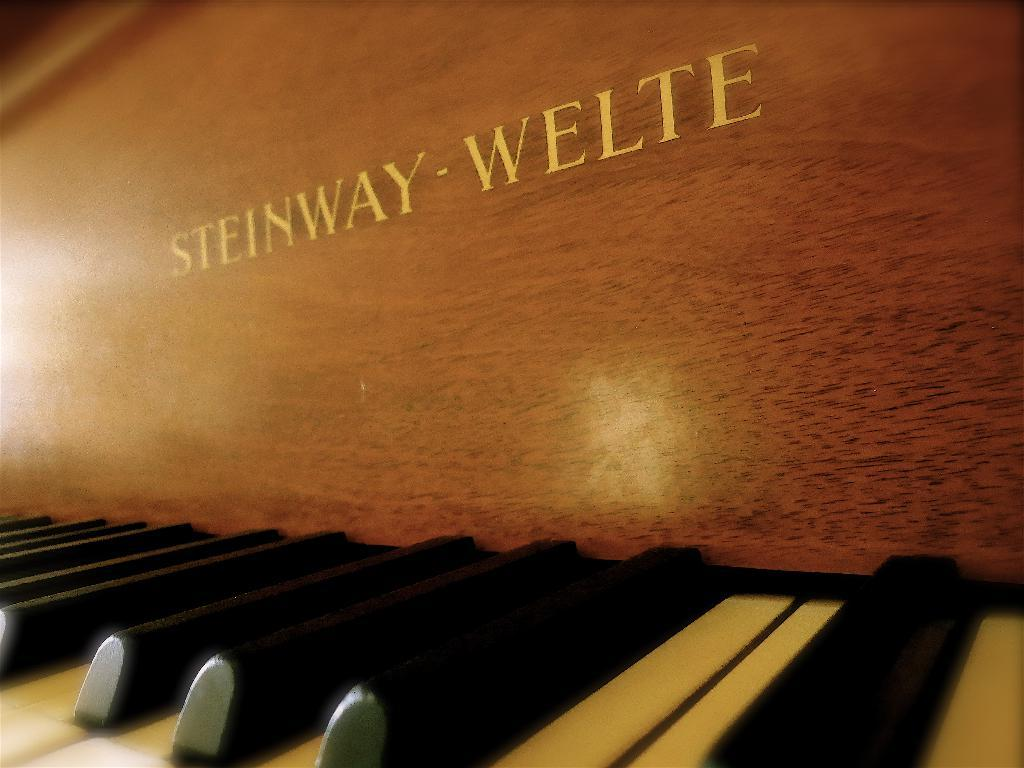What musical instrument is present in the image? There is a piano in the image. What are the keys on the piano like? The piano has black and white keys. What material is the piano made of? The piano is made of wood. How many houses are visible in the image? There are no houses present in the image; it features a piano. Can you describe the snow on the piano in the image? There is no snow present on the piano or in the image. 